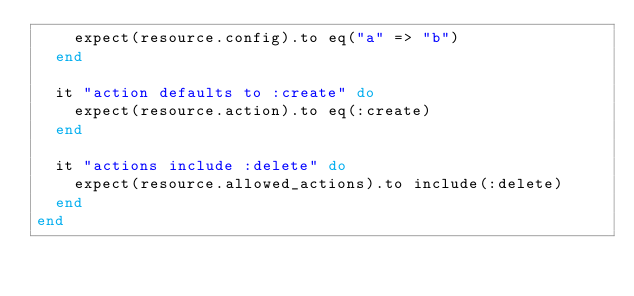Convert code to text. <code><loc_0><loc_0><loc_500><loc_500><_Ruby_>    expect(resource.config).to eq("a" => "b")
  end

  it "action defaults to :create" do
    expect(resource.action).to eq(:create)
  end

  it "actions include :delete" do
    expect(resource.allowed_actions).to include(:delete)
  end
end
</code> 